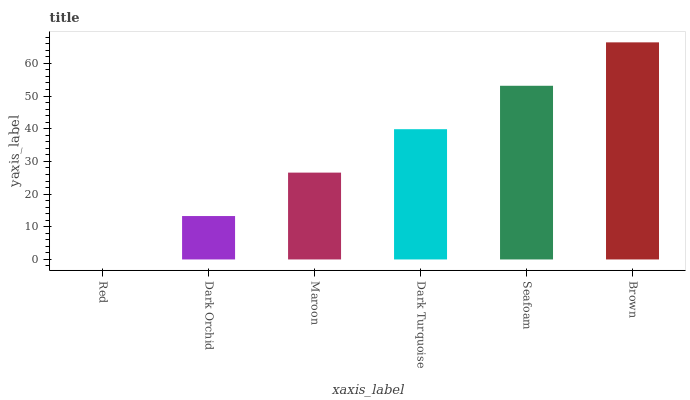Is Red the minimum?
Answer yes or no. Yes. Is Brown the maximum?
Answer yes or no. Yes. Is Dark Orchid the minimum?
Answer yes or no. No. Is Dark Orchid the maximum?
Answer yes or no. No. Is Dark Orchid greater than Red?
Answer yes or no. Yes. Is Red less than Dark Orchid?
Answer yes or no. Yes. Is Red greater than Dark Orchid?
Answer yes or no. No. Is Dark Orchid less than Red?
Answer yes or no. No. Is Dark Turquoise the high median?
Answer yes or no. Yes. Is Maroon the low median?
Answer yes or no. Yes. Is Dark Orchid the high median?
Answer yes or no. No. Is Dark Orchid the low median?
Answer yes or no. No. 